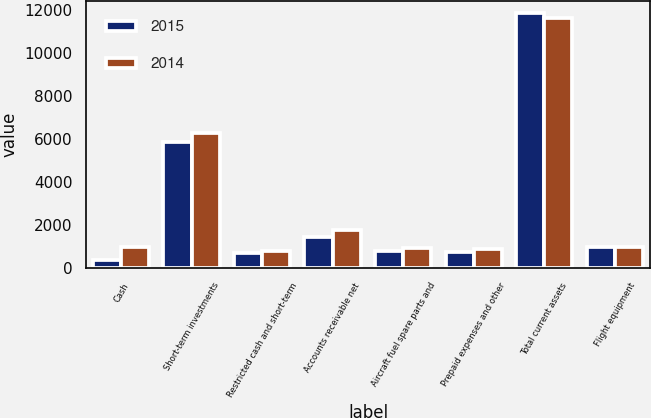<chart> <loc_0><loc_0><loc_500><loc_500><stacked_bar_chart><ecel><fcel>Cash<fcel>Short-term investments<fcel>Restricted cash and short-term<fcel>Accounts receivable net<fcel>Aircraft fuel spare parts and<fcel>Prepaid expenses and other<fcel>Total current assets<fcel>Flight equipment<nl><fcel>2015<fcel>364<fcel>5862<fcel>695<fcel>1420<fcel>796<fcel>740<fcel>11858<fcel>951.5<nl><fcel>2014<fcel>984<fcel>6306<fcel>774<fcel>1769<fcel>919<fcel>885<fcel>11637<fcel>951.5<nl></chart> 